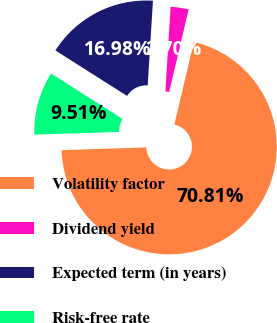<chart> <loc_0><loc_0><loc_500><loc_500><pie_chart><fcel>Volatility factor<fcel>Dividend yield<fcel>Expected term (in years)<fcel>Risk-free rate<nl><fcel>70.81%<fcel>2.7%<fcel>16.98%<fcel>9.51%<nl></chart> 